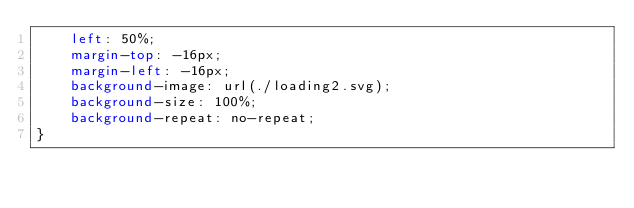<code> <loc_0><loc_0><loc_500><loc_500><_CSS_>    left: 50%;
    margin-top: -16px;
    margin-left: -16px;
    background-image: url(./loading2.svg);
    background-size: 100%;
    background-repeat: no-repeat;
}
</code> 